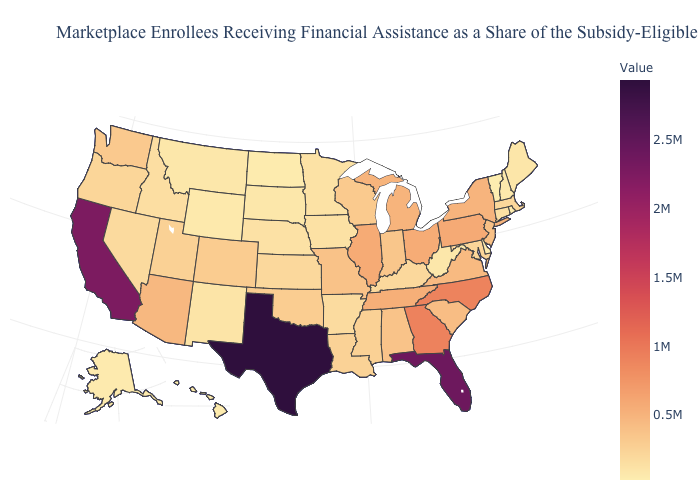Does North Dakota have the lowest value in the MidWest?
Answer briefly. Yes. Is the legend a continuous bar?
Keep it brief. Yes. 